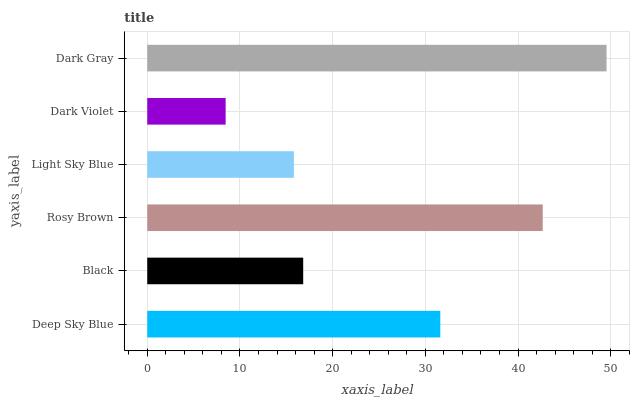Is Dark Violet the minimum?
Answer yes or no. Yes. Is Dark Gray the maximum?
Answer yes or no. Yes. Is Black the minimum?
Answer yes or no. No. Is Black the maximum?
Answer yes or no. No. Is Deep Sky Blue greater than Black?
Answer yes or no. Yes. Is Black less than Deep Sky Blue?
Answer yes or no. Yes. Is Black greater than Deep Sky Blue?
Answer yes or no. No. Is Deep Sky Blue less than Black?
Answer yes or no. No. Is Deep Sky Blue the high median?
Answer yes or no. Yes. Is Black the low median?
Answer yes or no. Yes. Is Black the high median?
Answer yes or no. No. Is Deep Sky Blue the low median?
Answer yes or no. No. 